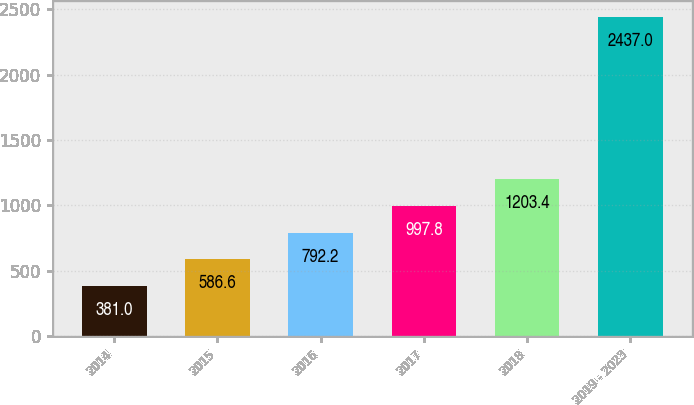Convert chart to OTSL. <chart><loc_0><loc_0><loc_500><loc_500><bar_chart><fcel>2014<fcel>2015<fcel>2016<fcel>2017<fcel>2018<fcel>2019 - 2023<nl><fcel>381<fcel>586.6<fcel>792.2<fcel>997.8<fcel>1203.4<fcel>2437<nl></chart> 